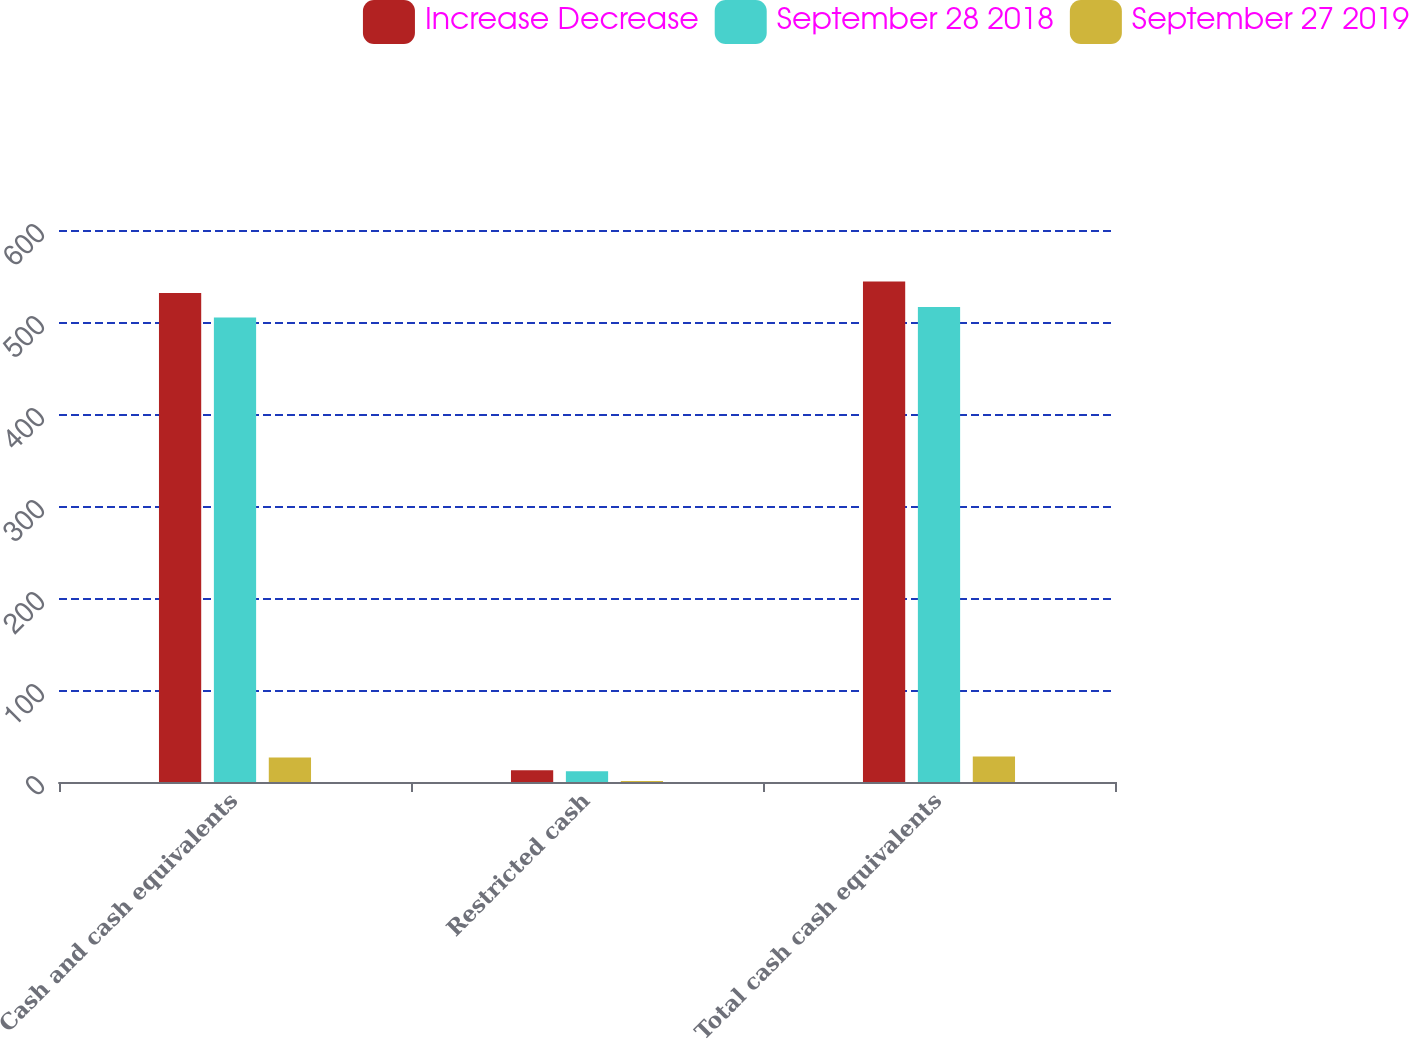Convert chart to OTSL. <chart><loc_0><loc_0><loc_500><loc_500><stacked_bar_chart><ecel><fcel>Cash and cash equivalents<fcel>Restricted cash<fcel>Total cash cash equivalents<nl><fcel>Increase Decrease<fcel>531.4<fcel>12.7<fcel>544.1<nl><fcel>September 28 2018<fcel>504.8<fcel>11.6<fcel>516.4<nl><fcel>September 27 2019<fcel>26.6<fcel>1.1<fcel>27.7<nl></chart> 